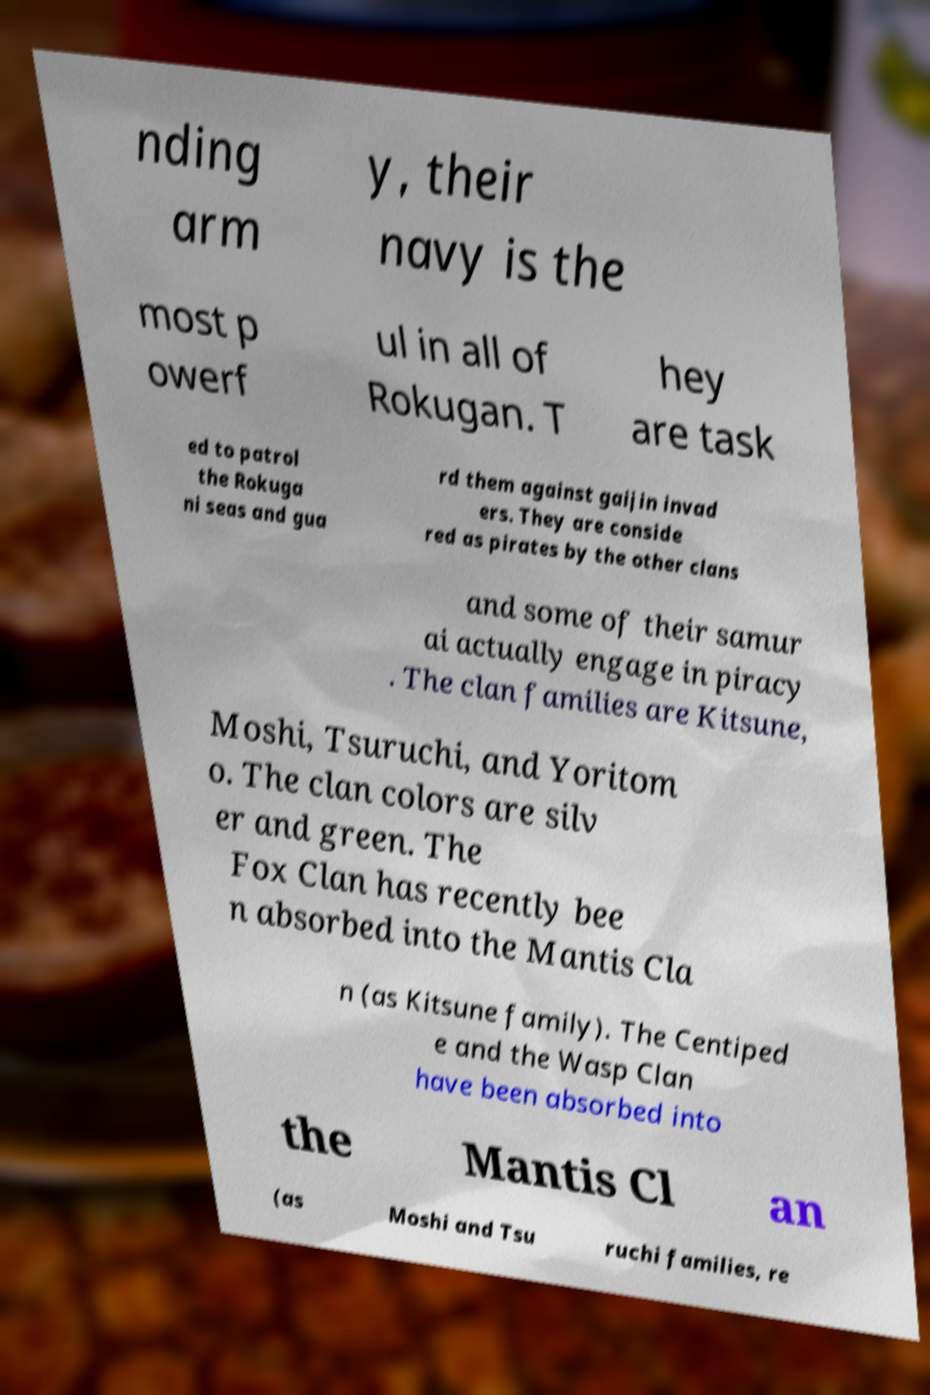Can you accurately transcribe the text from the provided image for me? nding arm y, their navy is the most p owerf ul in all of Rokugan. T hey are task ed to patrol the Rokuga ni seas and gua rd them against gaijin invad ers. They are conside red as pirates by the other clans and some of their samur ai actually engage in piracy . The clan families are Kitsune, Moshi, Tsuruchi, and Yoritom o. The clan colors are silv er and green. The Fox Clan has recently bee n absorbed into the Mantis Cla n (as Kitsune family). The Centiped e and the Wasp Clan have been absorbed into the Mantis Cl an (as Moshi and Tsu ruchi families, re 